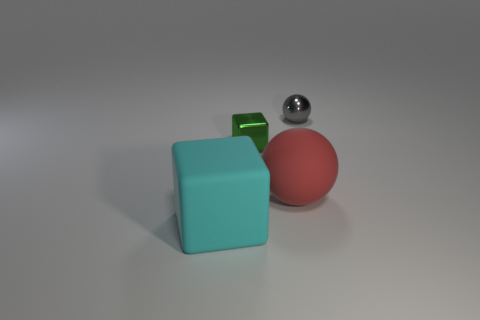How many other things are there of the same color as the matte sphere? There are no other objects in the image that share the exact matte red color of the sphere. 